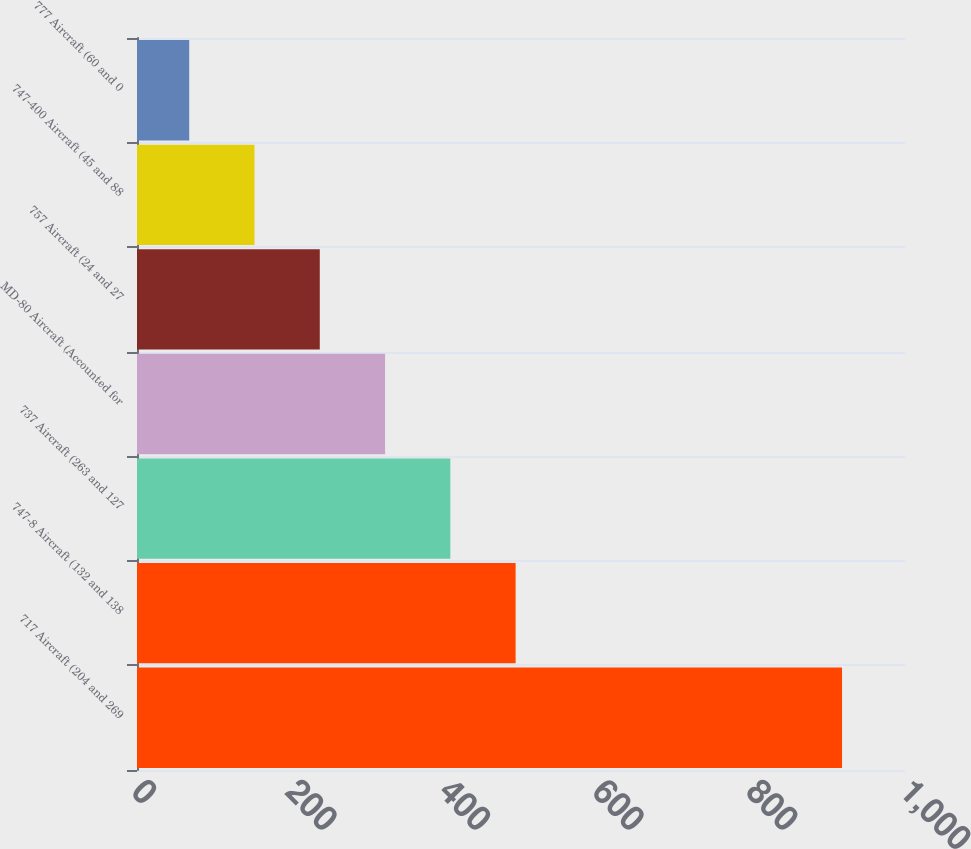<chart> <loc_0><loc_0><loc_500><loc_500><bar_chart><fcel>717 Aircraft (204 and 269<fcel>747-8 Aircraft (132 and 138<fcel>737 Aircraft (263 and 127<fcel>MD-80 Aircraft (Accounted for<fcel>757 Aircraft (24 and 27<fcel>747-400 Aircraft (45 and 88<fcel>777 Aircraft (60 and 0<nl><fcel>918<fcel>493<fcel>408<fcel>323<fcel>238<fcel>153<fcel>68<nl></chart> 